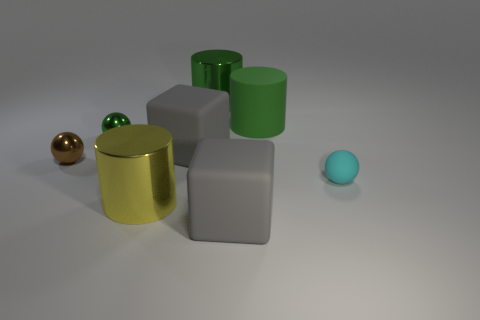What size is the cyan thing right of the gray matte cube that is right of the big gray rubber object that is behind the tiny cyan matte object?
Ensure brevity in your answer.  Small. How many red objects are metallic cylinders or big matte cubes?
Offer a terse response. 0. Does the large shiny thing in front of the cyan rubber thing have the same shape as the small rubber thing?
Offer a terse response. No. Is the number of metallic things on the right side of the yellow shiny cylinder greater than the number of cyan metallic objects?
Your answer should be very brief. Yes. What number of other cylinders are the same size as the green metallic cylinder?
Give a very brief answer. 2. There is another cylinder that is the same color as the matte cylinder; what is its size?
Provide a short and direct response. Large. What number of things are matte blocks or metallic cylinders behind the green ball?
Offer a terse response. 3. The thing that is right of the green metallic cylinder and behind the tiny green thing is what color?
Make the answer very short. Green. Do the yellow metal thing and the green rubber cylinder have the same size?
Provide a short and direct response. Yes. There is a cylinder that is in front of the tiny cyan rubber ball; what color is it?
Give a very brief answer. Yellow. 